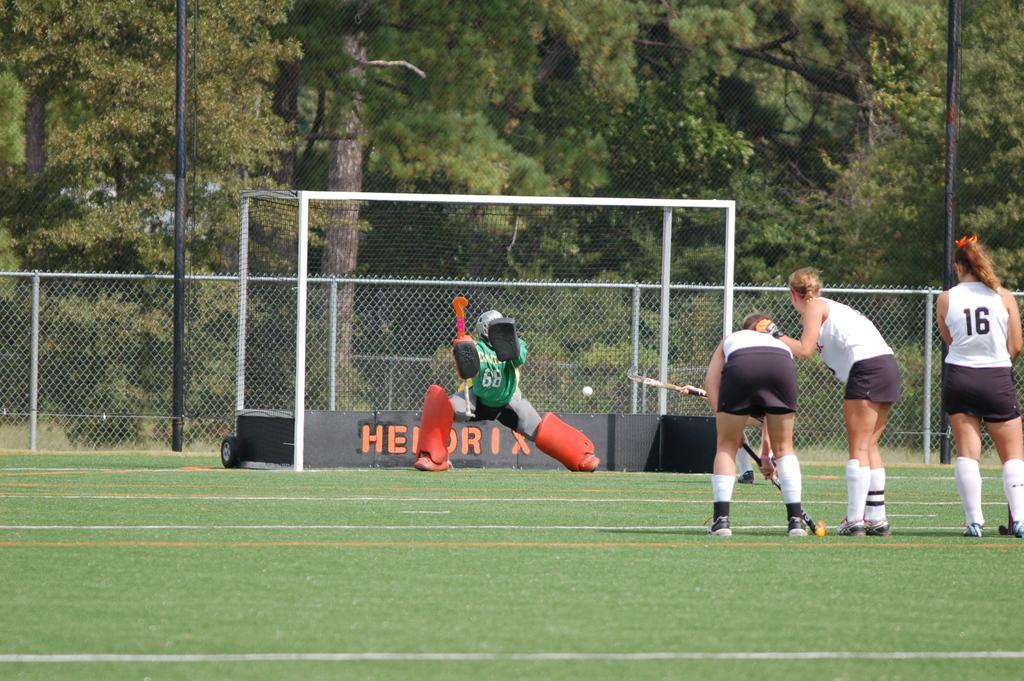<image>
Give a short and clear explanation of the subsequent image. people looking at a field hockey goalie in a green 68 jersey 